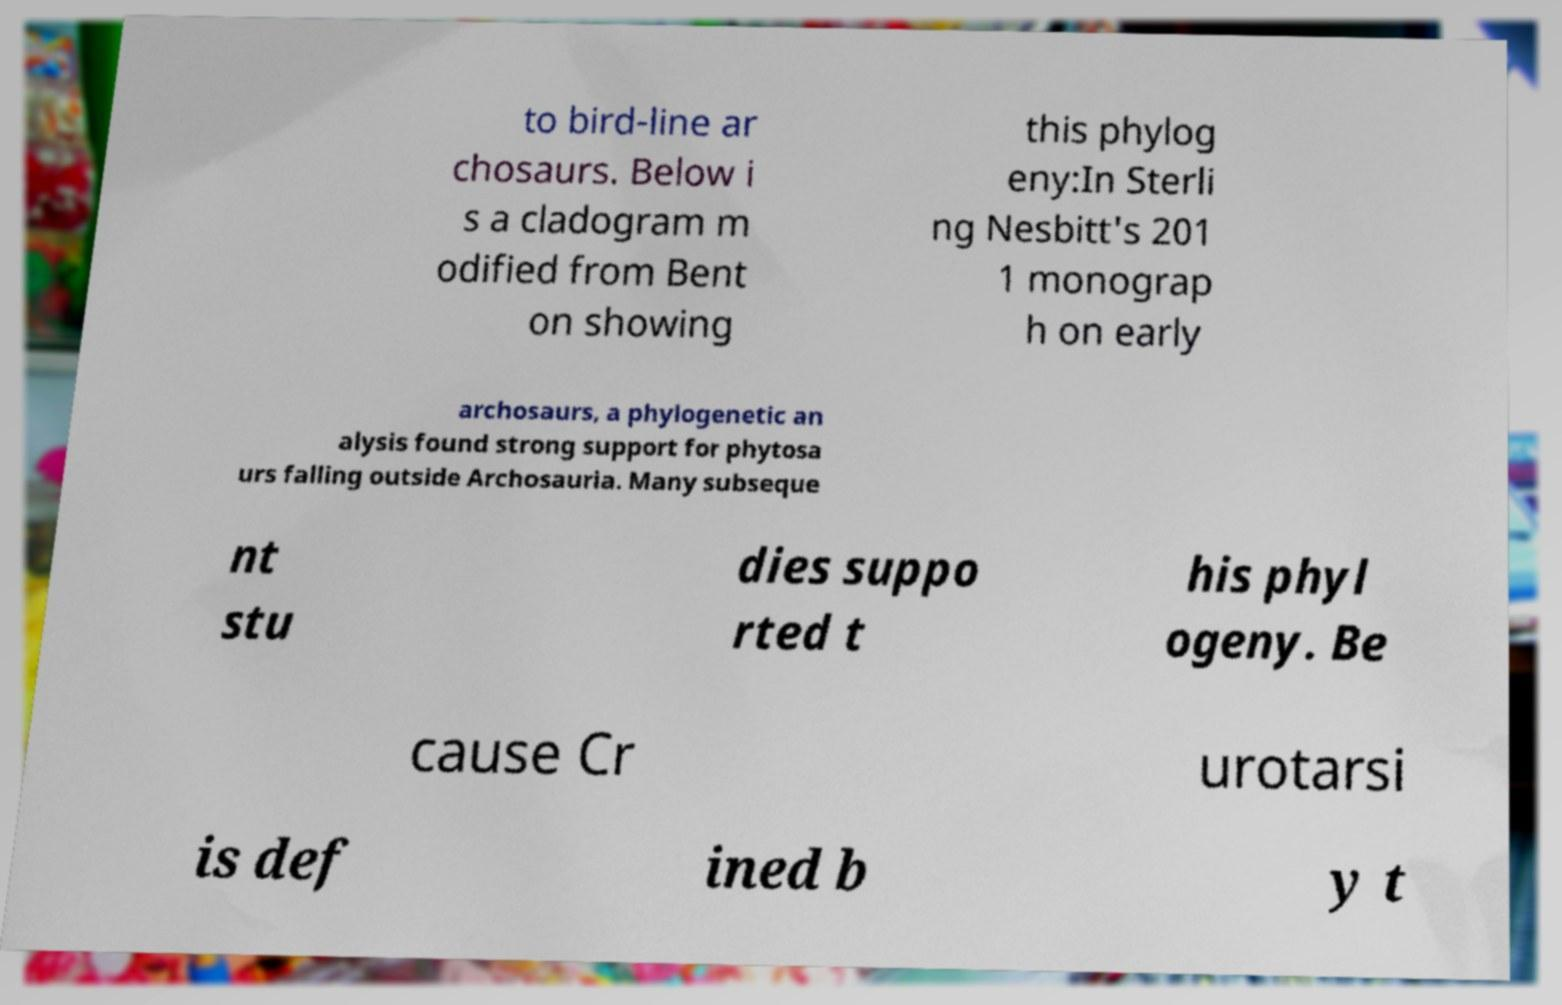Could you assist in decoding the text presented in this image and type it out clearly? to bird-line ar chosaurs. Below i s a cladogram m odified from Bent on showing this phylog eny:In Sterli ng Nesbitt's 201 1 monograp h on early archosaurs, a phylogenetic an alysis found strong support for phytosa urs falling outside Archosauria. Many subseque nt stu dies suppo rted t his phyl ogeny. Be cause Cr urotarsi is def ined b y t 